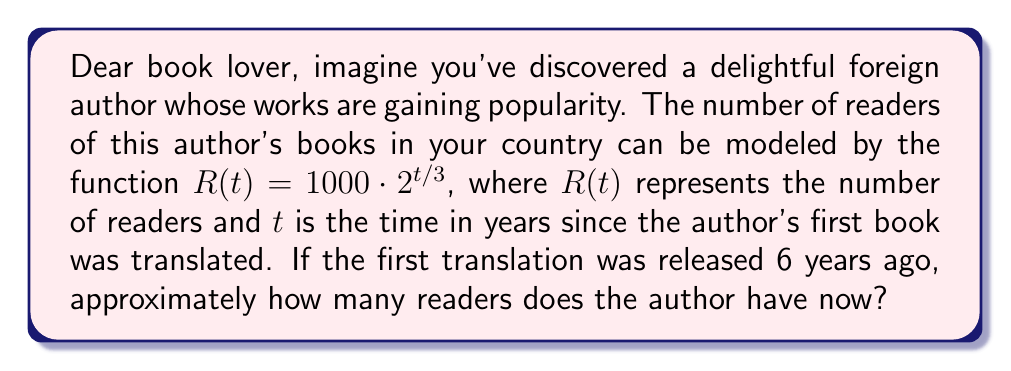Give your solution to this math problem. Let's approach this step-by-step:

1) We're given the function $R(t) = 1000 \cdot 2^{t/3}$, where:
   - $R(t)$ is the number of readers
   - $t$ is the time in years since the first translation
   - 1000 is the initial number of readers

2) We need to find $R(6)$ because 6 years have passed since the first translation.

3) Let's substitute $t = 6$ into our function:

   $R(6) = 1000 \cdot 2^{6/3}$

4) Simplify the exponent:
   
   $R(6) = 1000 \cdot 2^2$

5) Calculate $2^2$:
   
   $R(6) = 1000 \cdot 4$

6) Multiply:
   
   $R(6) = 4000$

Therefore, after 6 years, the author would have approximately 4000 readers.
Answer: The author has approximately 4000 readers after 6 years. 